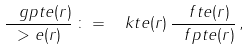Convert formula to latex. <formula><loc_0><loc_0><loc_500><loc_500>\frac { \ g p t e ( r ) } { > e ( r ) } \, \colon = \, \ k t e ( r ) \, \frac { \ f t e ( r ) } { \ f p t e ( r ) } \, ,</formula> 